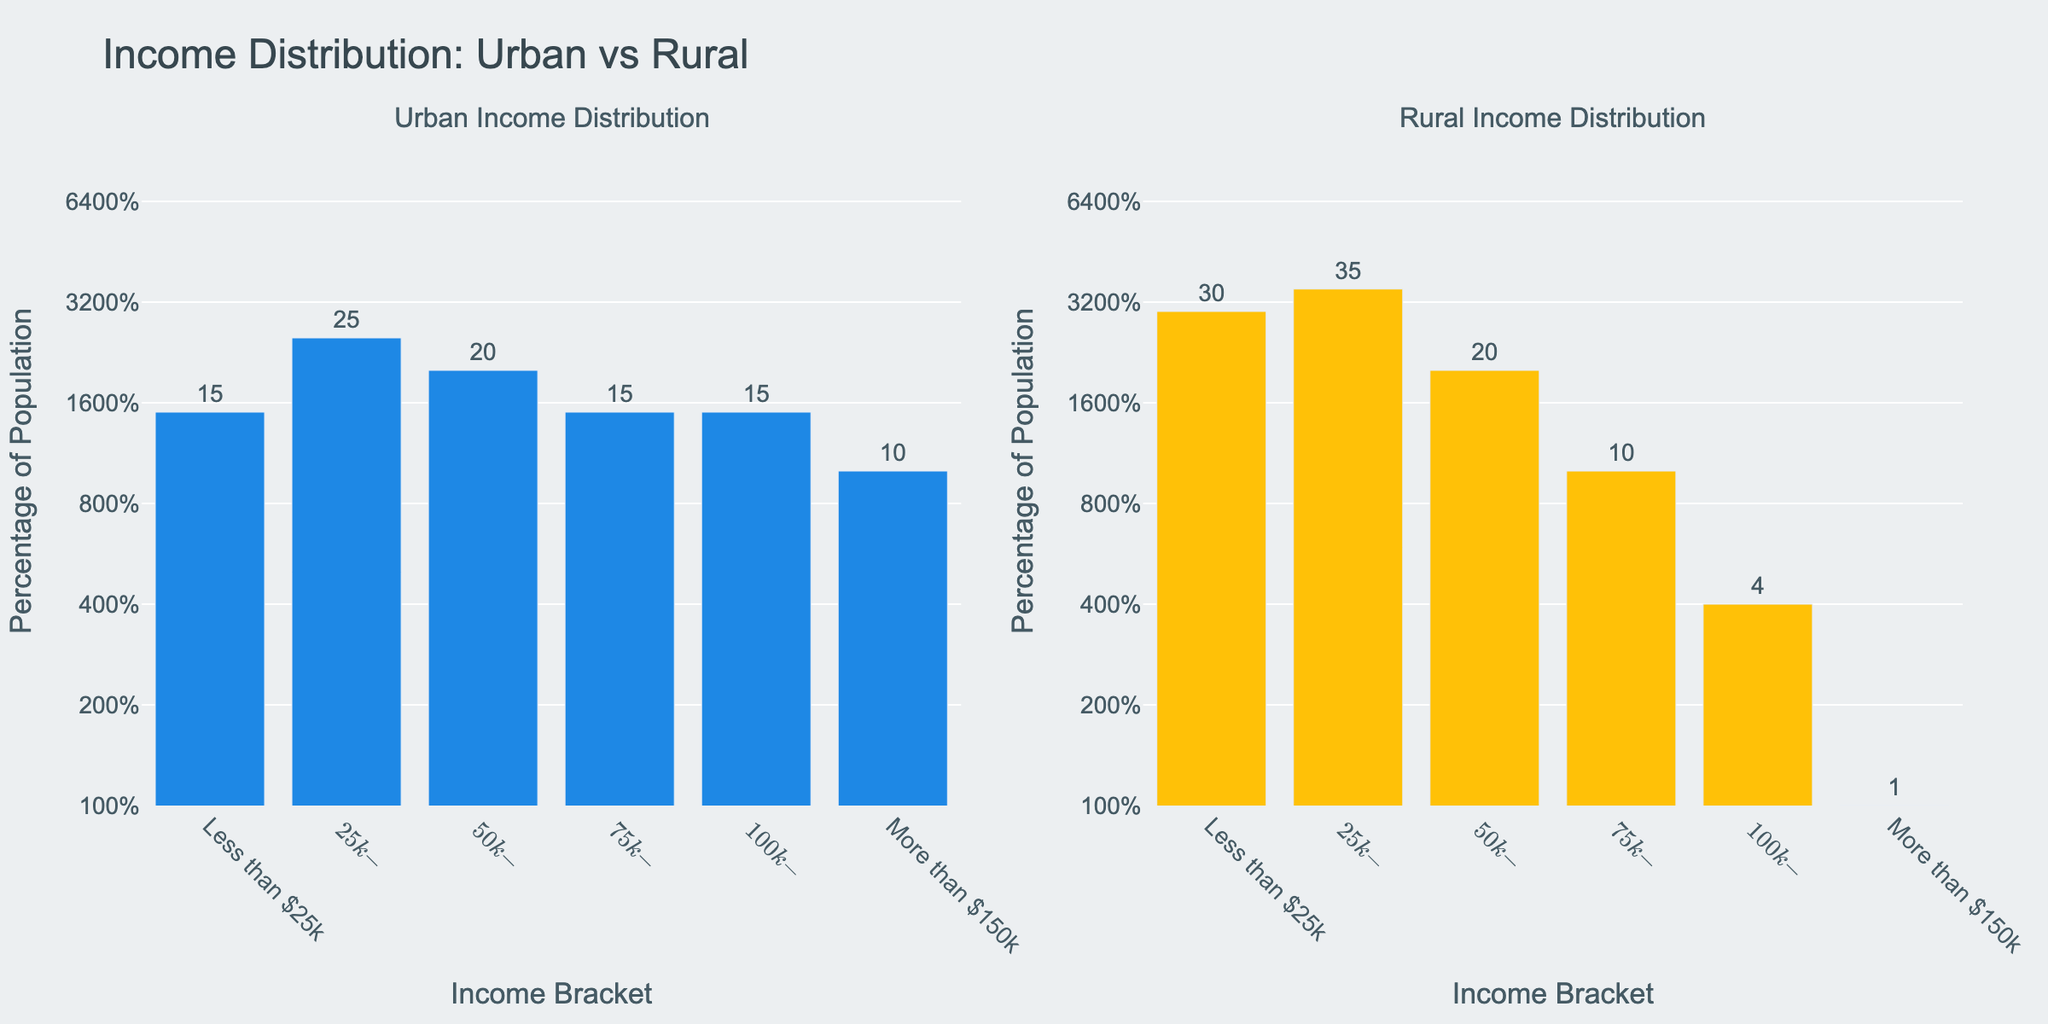What is the title of the figure? The title is usually located at the top of the plot and summarizes the content of the figure. In this case, the title is "Income Distribution: Urban vs Rural".
Answer: Income Distribution: Urban vs Rural What are the colors used in the bar plots for urban and rural areas? The color of the bars can be easily observed in the figure. The urban bars are colored in blue, and the rural bars are colored in yellow.
Answer: Blue for Urban, Yellow for Rural What income bracket has the highest percentage of population in rural areas? To find the answer, look at the rural sub-plot and identify the highest bar. The tallest bar corresponds to the $25k-$50k income bracket.
Answer: $25k-$50k What income bracket has the lowest percentage of population in urban areas? By examining the urban sub-plot and identifying the shortest bar, we find that "More than $150k" has the lowest percentage.
Answer: More than $150k How much higher is the percentage of the population in the "Less than $25k" bracket in rural areas compared to urban areas? Identify the heights of the "Less than $25k" bars in both urban and rural plots. Urban is at 15% and rural is at 30%. The difference is 30% - 15% = 15%.
Answer: 15% Which area, urban or rural, has a more even distribution of income across brackets? To determine evenness, observe the height of the bars across all income brackets. Urban areas show a more even distribution with less disparity compared to rural areas, where there is a steep drop after the $25k-$50k bracket.
Answer: Urban In which income bracket do rural areas have more than double the percentage of population compared to urban areas? Compare the percentages of each bracket in urban and rural plots. Rural has more than double the percentage of population in "Less than $25k" (30% vs. 15%).
Answer: Less than $25k What is the range of the y-axis in the figure? The y-axis range is indicated on the plot. Since the y-axis is in log scale, the range shown should cover from 1% to 100%.
Answer: 1% to 100% What proportion of the urban population earns less than $75,000? Add the percentages of the "Less than $25k", "$25k-$50k", and "$50k-$75k" brackets for urban areas: 15% + 25% + 20% = 60%.
Answer: 60% Is the "More than $150k" bracket population in rural areas even visible on the plot? Check the rural bar for "More than $150k". Given the y-axis starts at 1% on a log scale, a population percentage of 1% or less may not be visibly distinct.
Answer: No 